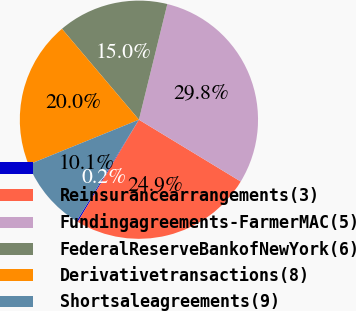Convert chart. <chart><loc_0><loc_0><loc_500><loc_500><pie_chart><ecel><fcel>Reinsurancearrangements(3)<fcel>Fundingagreements-FarmerMAC(5)<fcel>FederalReserveBankofNewYork(6)<fcel>Derivativetransactions(8)<fcel>Shortsaleagreements(9)<nl><fcel>0.19%<fcel>24.9%<fcel>29.85%<fcel>15.02%<fcel>19.96%<fcel>10.08%<nl></chart> 